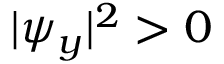Convert formula to latex. <formula><loc_0><loc_0><loc_500><loc_500>{ | \psi _ { y } | ^ { 2 } > 0 }</formula> 